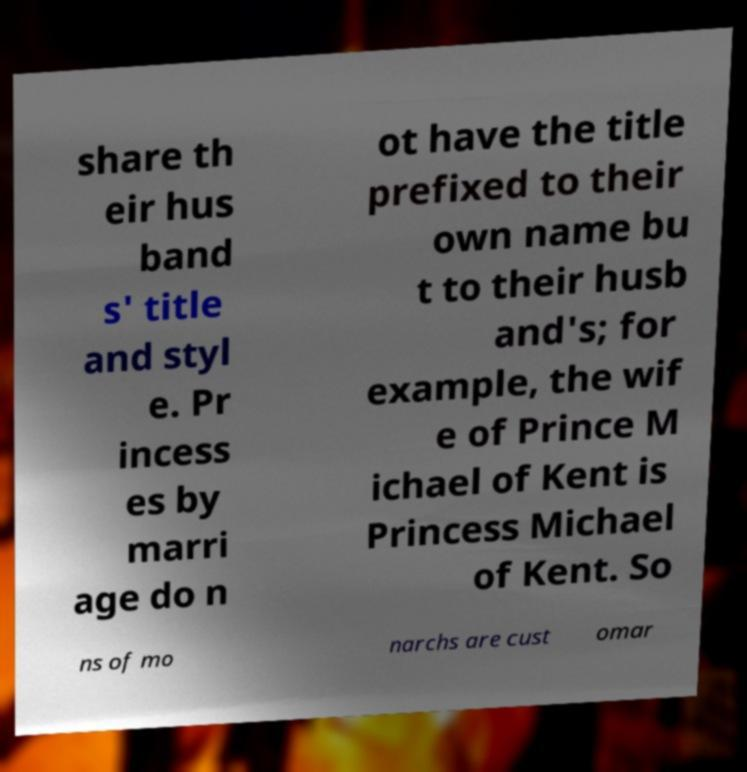I need the written content from this picture converted into text. Can you do that? share th eir hus band s' title and styl e. Pr incess es by marri age do n ot have the title prefixed to their own name bu t to their husb and's; for example, the wif e of Prince M ichael of Kent is Princess Michael of Kent. So ns of mo narchs are cust omar 